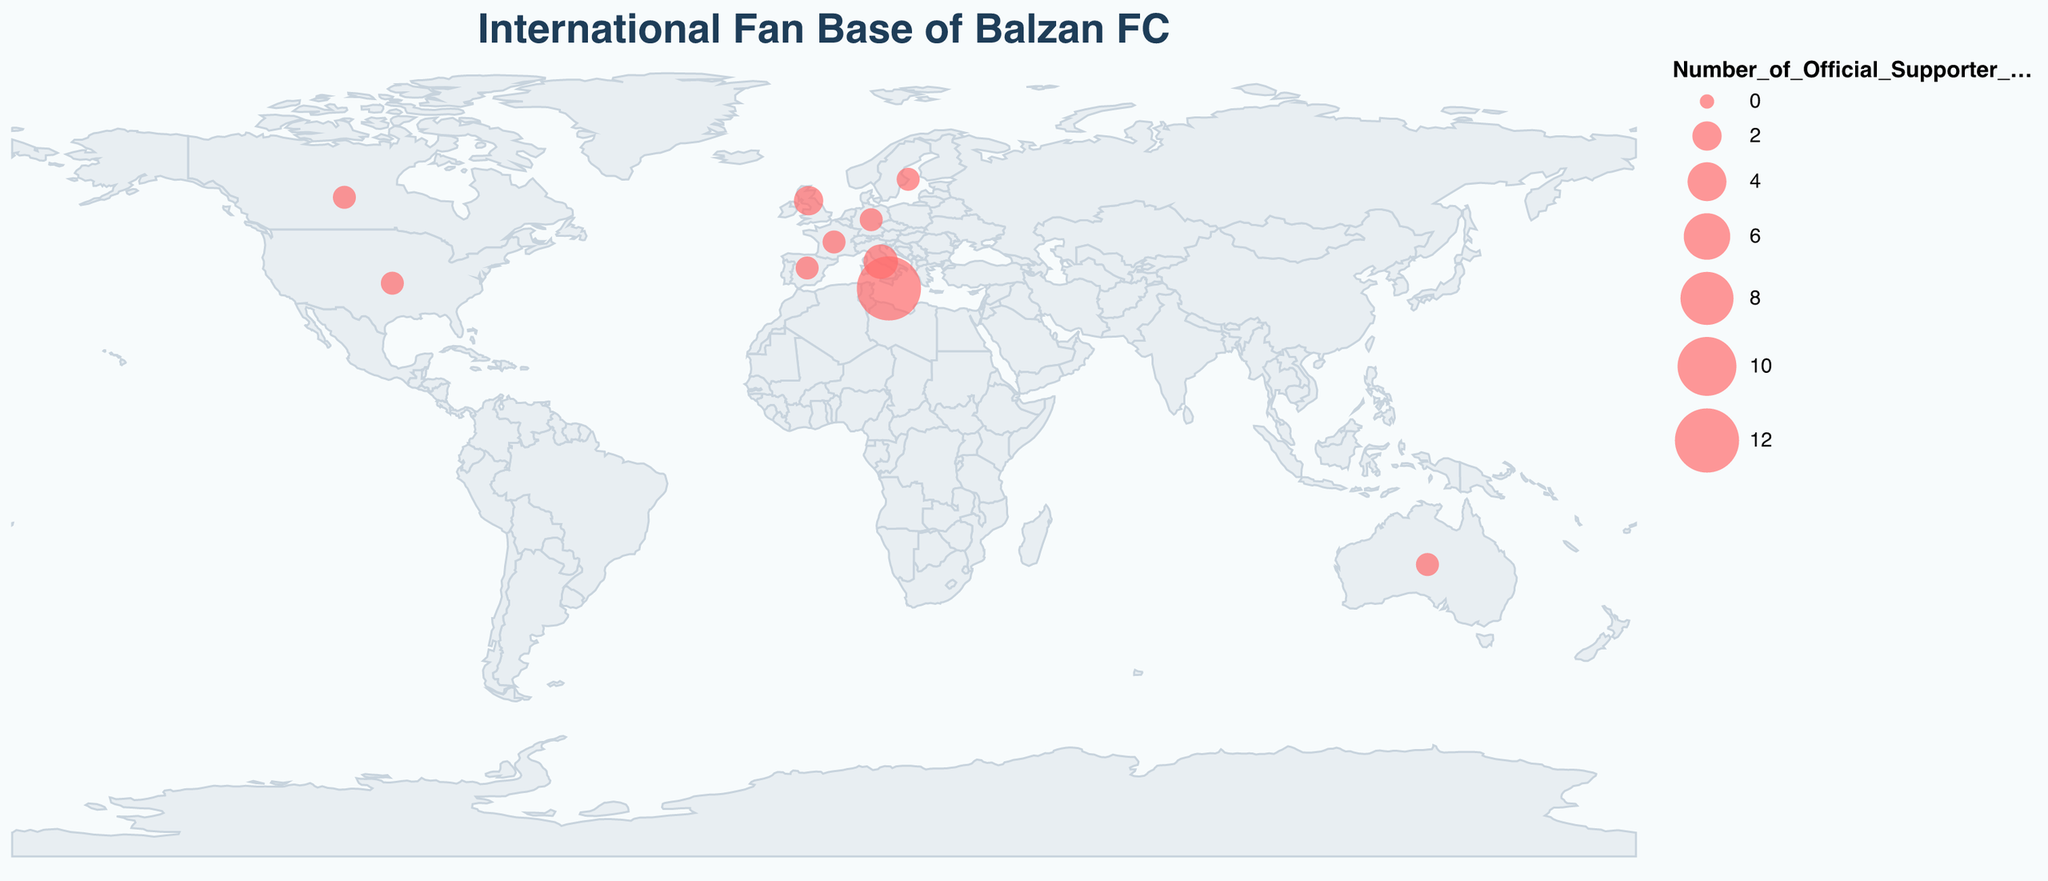What's the title of the plot? The title is displayed prominently at the top of the figure in a larger font size and a distinct color. The title of this figure is "International Fan Base of Balzan FC".
Answer: International Fan Base of Balzan FC How many countries are shown to have official supporter groups for Balzan FC? By counting the individual data points marked on the map, we can see that there are 10 countries with official supporter groups for Balzan FC.
Answer: 10 Which country has the highest number of official supporter groups? Reviewing the size of the circles and the provided dataset, it is evident that Malta has the largest circle, indicating the highest number of official supporter groups. Malta is confirmed to have 12 groups.
Answer: Malta How many official supporter groups are there in total across all countries? To find the total, sum the number of official supporter groups in each country: 12 (Malta) + 3 (Italy) + 2 (United Kingdom) + 1 (Australia) + 1 (Germany) + 1 (United States) + 1 (Spain) + 1 (France) + 1 (Canada) + 1 (Sweden). This totals to 24.
Answer: 24 Which continent has the most official supporter groups, and how many groups are there? Grouping the countries by continent:
- Europe: Malta (12), Italy (3), United Kingdom (2), Germany (1), Spain (1), France (1), Sweden (1) = 21
- North America: United States (1), Canada (1) = 2
- Oceania: Australia (1)
Europe clearly has the most supporter groups with a total of 21.
Answer: Europe, 21 What's the average number of supporter groups per country where the groups are present? To find the average, we divide the total number of supporter groups (24) by the number of countries (10). So, 24 ÷ 10 = 2.4.
Answer: 2.4 Which country outside Europe has the most supporter groups? By examining the non-European countries, we see that Australia, the United States, and Canada each have 1 supporter group. Therefore, they are tied for having the most groups outside Europe.
Answer: Australia, United States, Canada How does the number of supporter groups in Italy compare to the United Kingdom? Italy has 3 supporter groups, while the United Kingdom has 2. Italy has 1 more supporter group compared to the United Kingdom.
Answer: Italy has 1 more than United Kingdom Are there any countries with the same number of supporter groups? By looking at the dataset, we notice multiple countries have exactly 1 supporter group: Australia, Germany, United States, Spain, France, Canada, and Sweden.
Answer: Yes, multiple countries have 1 supporter group How many supporter groups are there in Europe aside from those in Malta? Exclude Malta from the European countries and sum the remaining groups: 
Italy (3) + United Kingdom (2) + Germany (1) + Spain (1) + France (1) + Sweden (1) = 9.
Answer: 9 